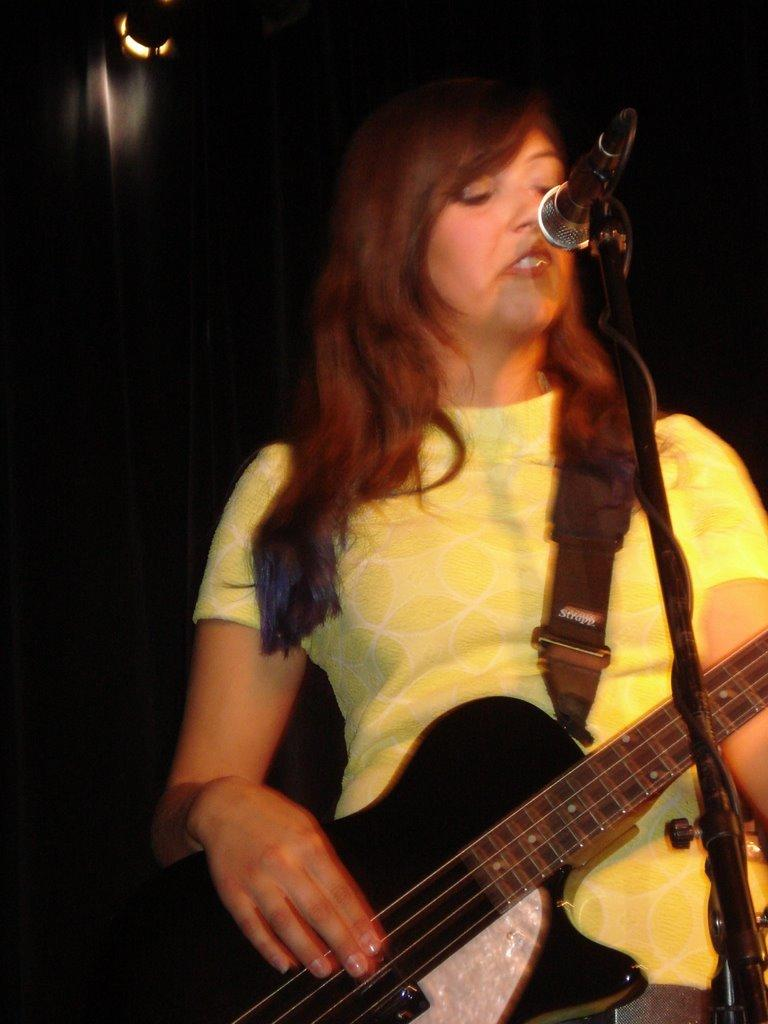What is the woman in the image doing? The woman is playing a guitar in the image. What is the woman standing in front of? The woman is in front of a microphone in the image. What is the woman wearing? The woman is wearing a yellow t-shirt in the image. What can be seen attached to the microphone? There is a microphone with a holder in the image. What type of desk can be seen in the image? There is no desk present in the image. 